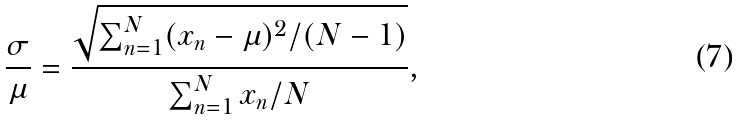<formula> <loc_0><loc_0><loc_500><loc_500>\frac { \sigma } { \mu } = \frac { \sqrt { \sum _ { n = 1 } ^ { N } ( x _ { n } - \mu ) ^ { 2 } / ( N - 1 ) } } { \sum _ { n = 1 } ^ { N } x _ { n } / N } ,</formula> 